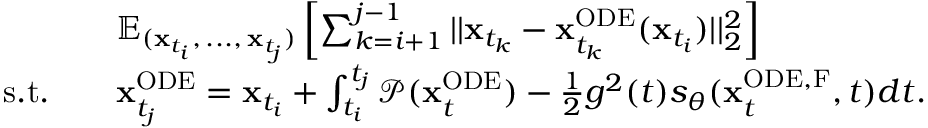Convert formula to latex. <formula><loc_0><loc_0><loc_500><loc_500>\begin{array} { r l } & { \mathbb { E } _ { ( x _ { t _ { i } } , \, \dots , \, x _ { t _ { j } } ) } \left [ \sum _ { k = i + 1 } ^ { j - 1 } | | x _ { t _ { k } } - x _ { t _ { k } } ^ { O D E } ( x _ { t _ { i } } ) | | _ { 2 } ^ { 2 } \right ] } \\ { s . t . \quad } & { x _ { t _ { j } } ^ { O D E } = x _ { t _ { i } } + \int _ { t _ { i } } ^ { t _ { j } } \mathcal { P } ( x _ { t } ^ { O D E } ) - \frac { 1 } { 2 } g ^ { 2 } ( t ) s _ { \theta } ( x _ { t } ^ { O D E , F } , t ) d t . } \end{array}</formula> 